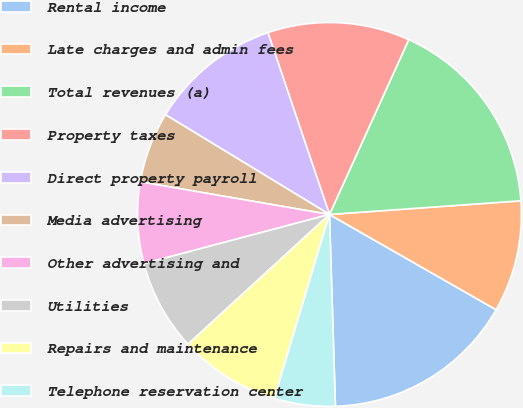Convert chart. <chart><loc_0><loc_0><loc_500><loc_500><pie_chart><fcel>Rental income<fcel>Late charges and admin fees<fcel>Total revenues (a)<fcel>Property taxes<fcel>Direct property payroll<fcel>Media advertising<fcel>Other advertising and<fcel>Utilities<fcel>Repairs and maintenance<fcel>Telephone reservation center<nl><fcel>16.24%<fcel>9.4%<fcel>17.09%<fcel>11.97%<fcel>11.11%<fcel>5.98%<fcel>6.84%<fcel>7.69%<fcel>8.55%<fcel>5.13%<nl></chart> 